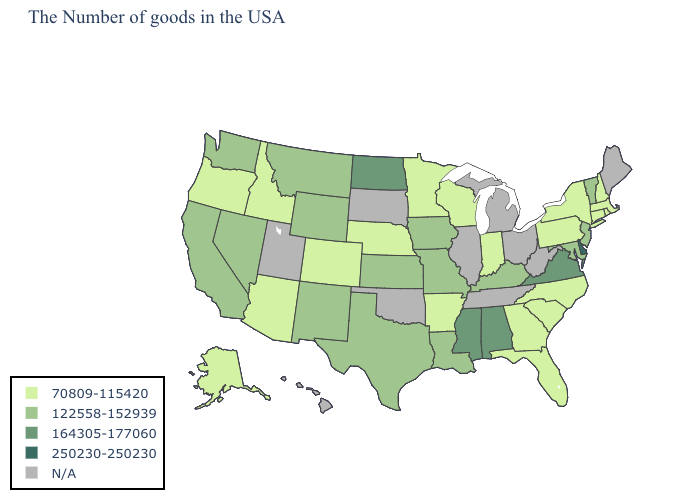Does Missouri have the highest value in the MidWest?
Give a very brief answer. No. Name the states that have a value in the range 70809-115420?
Answer briefly. Massachusetts, Rhode Island, New Hampshire, Connecticut, New York, Pennsylvania, North Carolina, South Carolina, Florida, Georgia, Indiana, Wisconsin, Arkansas, Minnesota, Nebraska, Colorado, Arizona, Idaho, Oregon, Alaska. Does the first symbol in the legend represent the smallest category?
Concise answer only. Yes. Name the states that have a value in the range N/A?
Quick response, please. Maine, West Virginia, Ohio, Michigan, Tennessee, Illinois, Oklahoma, South Dakota, Utah, Hawaii. Does North Dakota have the lowest value in the USA?
Quick response, please. No. What is the value of Alabama?
Be succinct. 164305-177060. What is the value of Michigan?
Give a very brief answer. N/A. What is the value of North Carolina?
Be succinct. 70809-115420. Name the states that have a value in the range N/A?
Answer briefly. Maine, West Virginia, Ohio, Michigan, Tennessee, Illinois, Oklahoma, South Dakota, Utah, Hawaii. What is the lowest value in states that border South Carolina?
Be succinct. 70809-115420. Among the states that border Oregon , which have the highest value?
Concise answer only. Nevada, California, Washington. Does Iowa have the lowest value in the MidWest?
Write a very short answer. No. Name the states that have a value in the range 250230-250230?
Concise answer only. Delaware. 